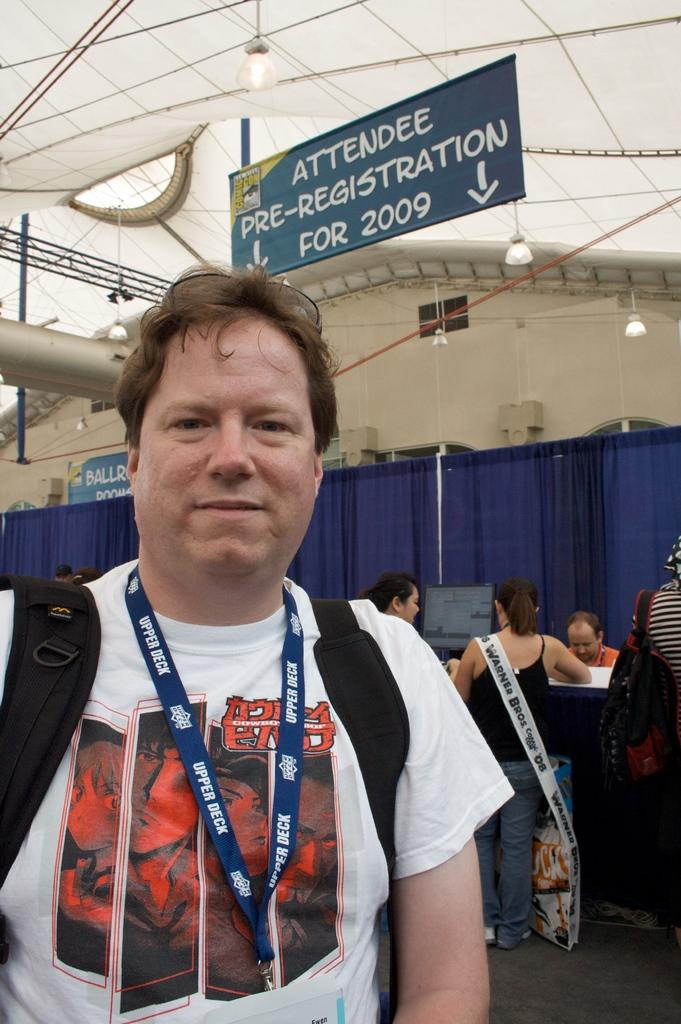<image>
Write a terse but informative summary of the picture. The man is standing in front of a attendee pre-registration sign. 